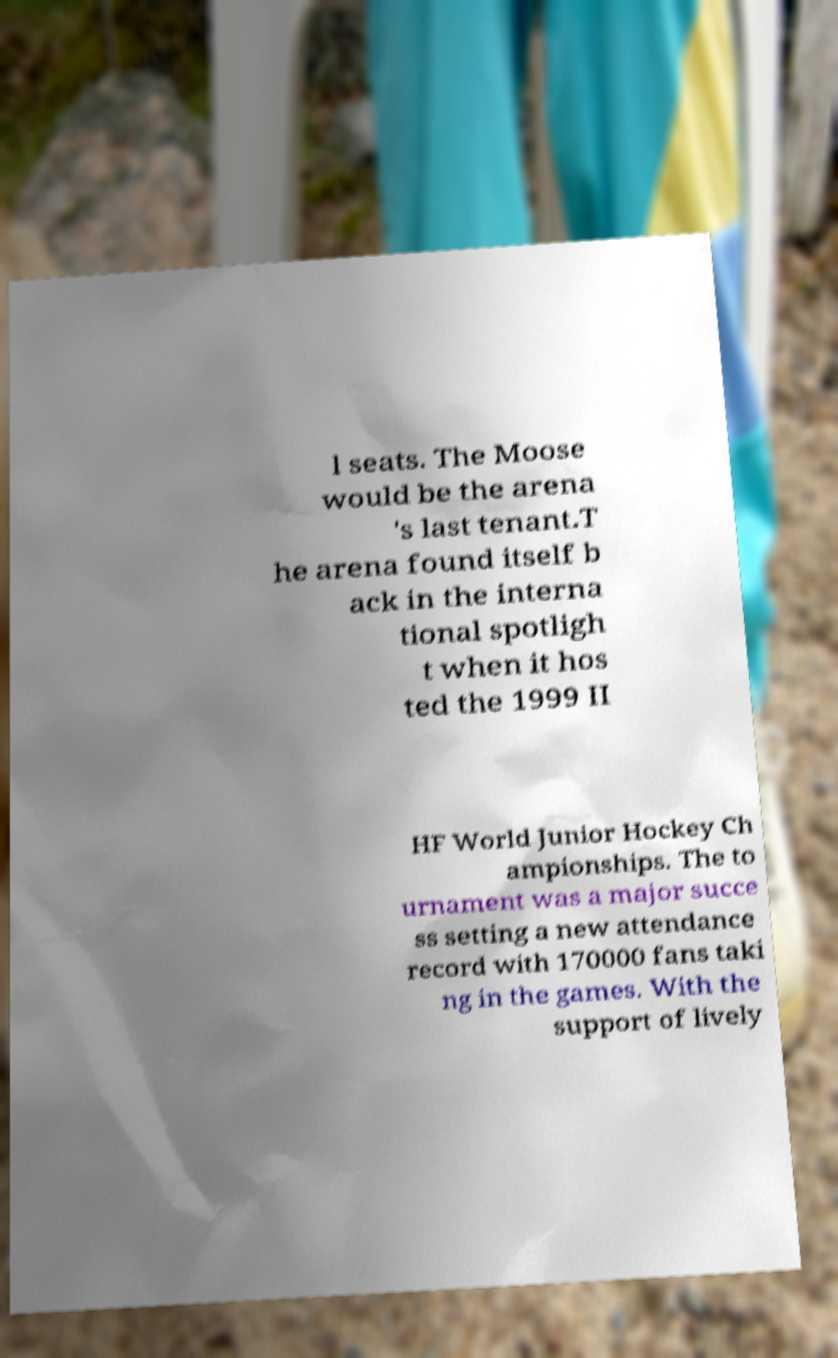Can you read and provide the text displayed in the image?This photo seems to have some interesting text. Can you extract and type it out for me? l seats. The Moose would be the arena 's last tenant.T he arena found itself b ack in the interna tional spotligh t when it hos ted the 1999 II HF World Junior Hockey Ch ampionships. The to urnament was a major succe ss setting a new attendance record with 170000 fans taki ng in the games. With the support of lively 